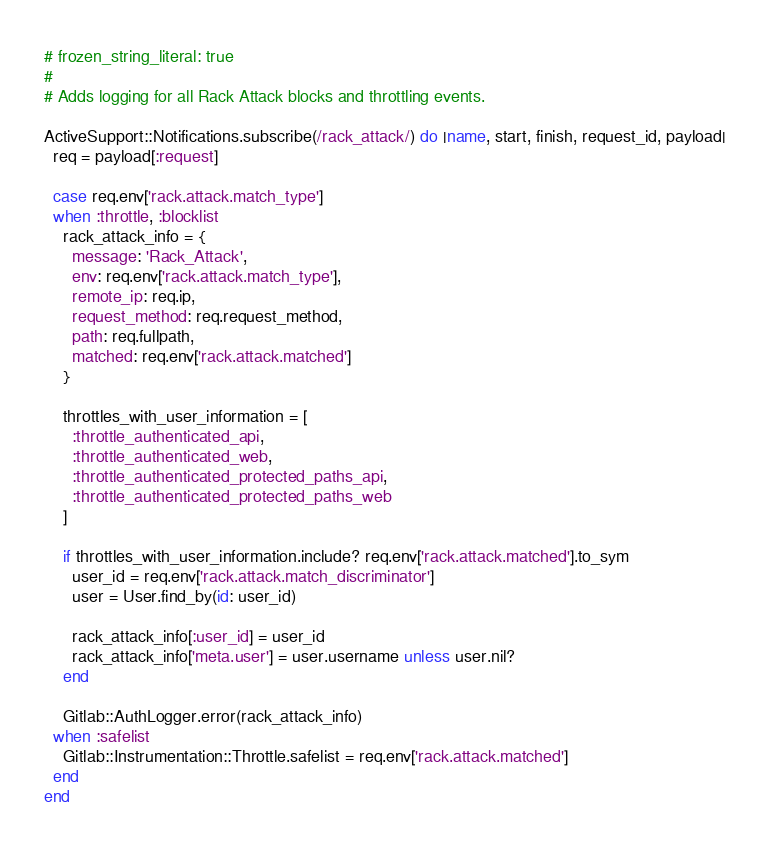<code> <loc_0><loc_0><loc_500><loc_500><_Ruby_># frozen_string_literal: true
#
# Adds logging for all Rack Attack blocks and throttling events.

ActiveSupport::Notifications.subscribe(/rack_attack/) do |name, start, finish, request_id, payload|
  req = payload[:request]

  case req.env['rack.attack.match_type']
  when :throttle, :blocklist
    rack_attack_info = {
      message: 'Rack_Attack',
      env: req.env['rack.attack.match_type'],
      remote_ip: req.ip,
      request_method: req.request_method,
      path: req.fullpath,
      matched: req.env['rack.attack.matched']
    }

    throttles_with_user_information = [
      :throttle_authenticated_api,
      :throttle_authenticated_web,
      :throttle_authenticated_protected_paths_api,
      :throttle_authenticated_protected_paths_web
    ]

    if throttles_with_user_information.include? req.env['rack.attack.matched'].to_sym
      user_id = req.env['rack.attack.match_discriminator']
      user = User.find_by(id: user_id)

      rack_attack_info[:user_id] = user_id
      rack_attack_info['meta.user'] = user.username unless user.nil?
    end

    Gitlab::AuthLogger.error(rack_attack_info)
  when :safelist
    Gitlab::Instrumentation::Throttle.safelist = req.env['rack.attack.matched']
  end
end
</code> 